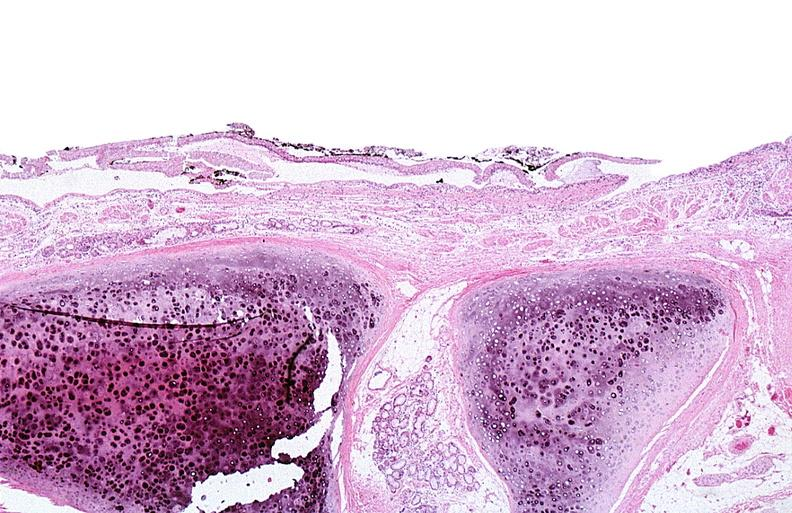where is this?
Answer the question using a single word or phrase. Skin 